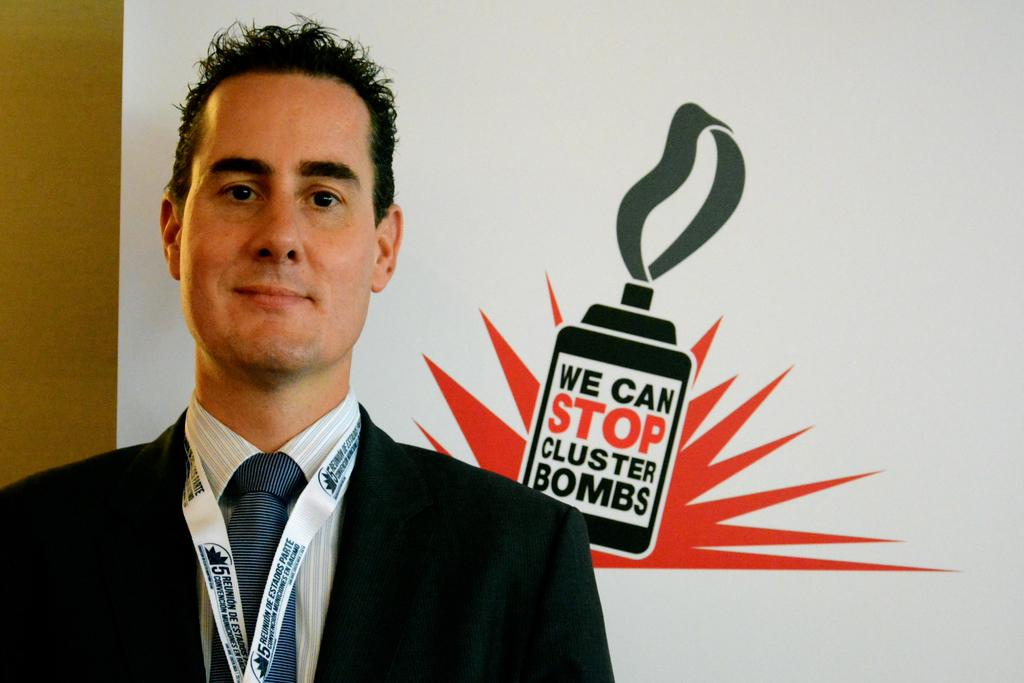Who is present in the image? There is a man in the image. Where is the man located in the image? The man is on the left side of the image. What is the man wearing? The man is wearing a black jacket, shirt, and tie. What is the man's facial expression? The man is smiling. What can be seen on the right side of the image? There is a white poster in the image. What is depicted on the poster? The poster has an image on it. What else is present on the poster? There is writing on the poster. How many shoes can be seen on the man's feet in the image? There is no information about the man's shoes in the image, so we cannot determine how many shoes he is wearing. What time is displayed on the clocks in the image? There are no clocks present in the image. 